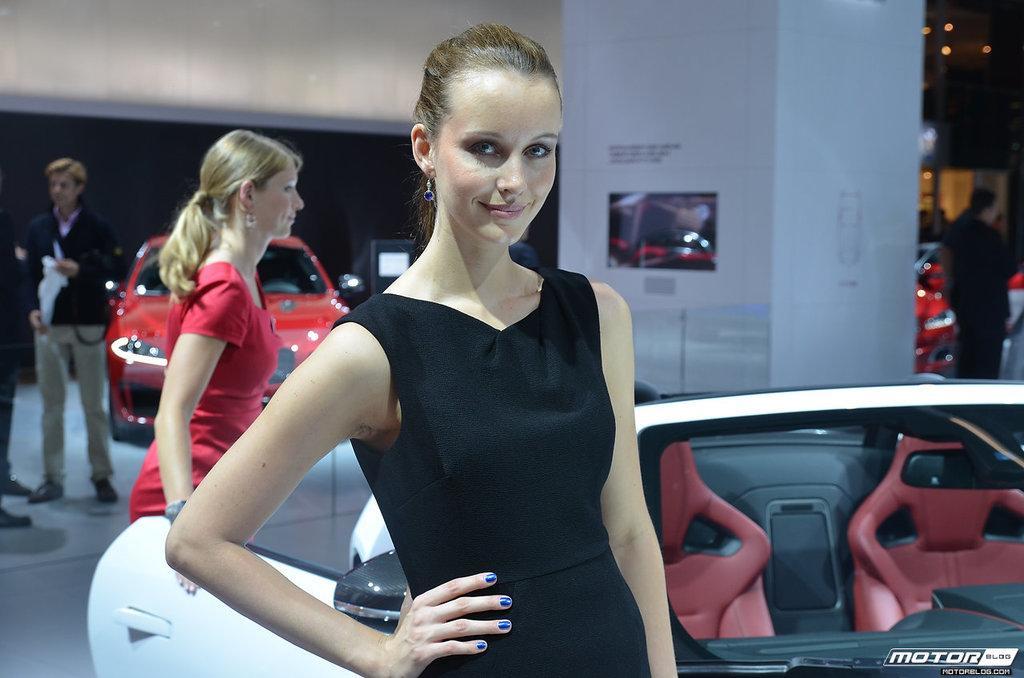Describe this image in one or two sentences. In this picture we can see a woman standing in the front, on the right side there is a white color car, in the background we can see some people and a red color car, there is a pillar and a screen here. 